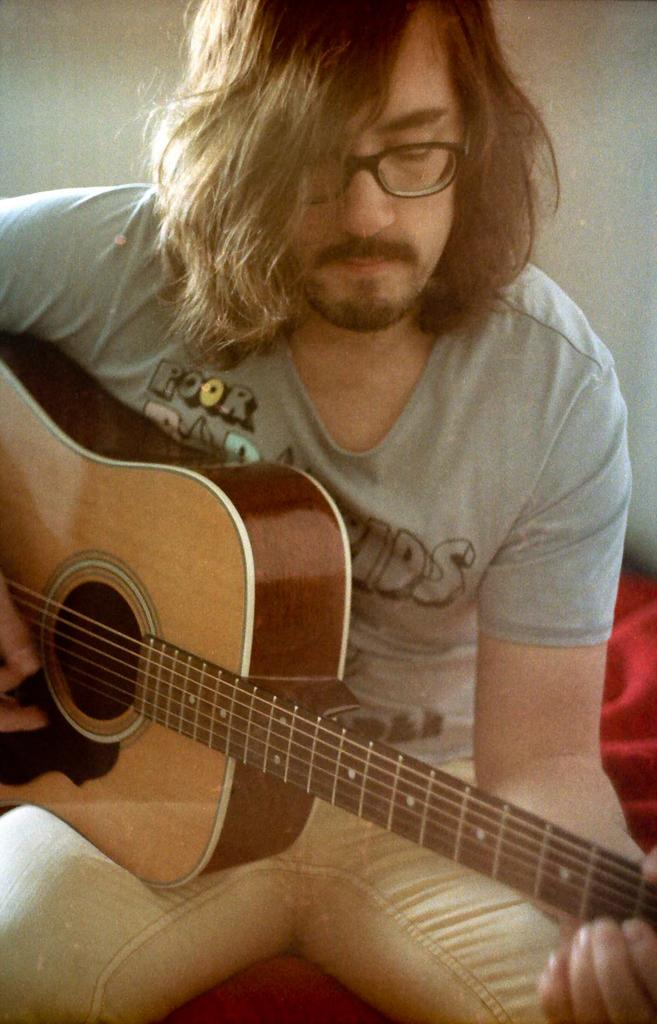What is the main subject of the image? There is a person in the image. What is the person doing in the image? The person is playing a guitar. Can you see a tiger playing the guitar alongside the person in the image? No, there is no tiger present in the image. How many steps does the person take while playing the guitar in the image? The image does not provide information about the person taking steps while playing the guitar. 